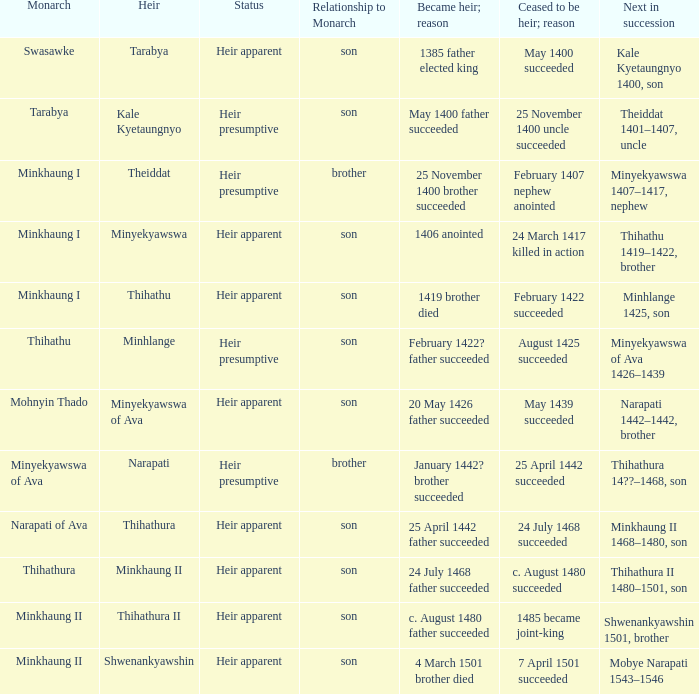What was the relationship to monarch of the heir Minyekyawswa? Son. 